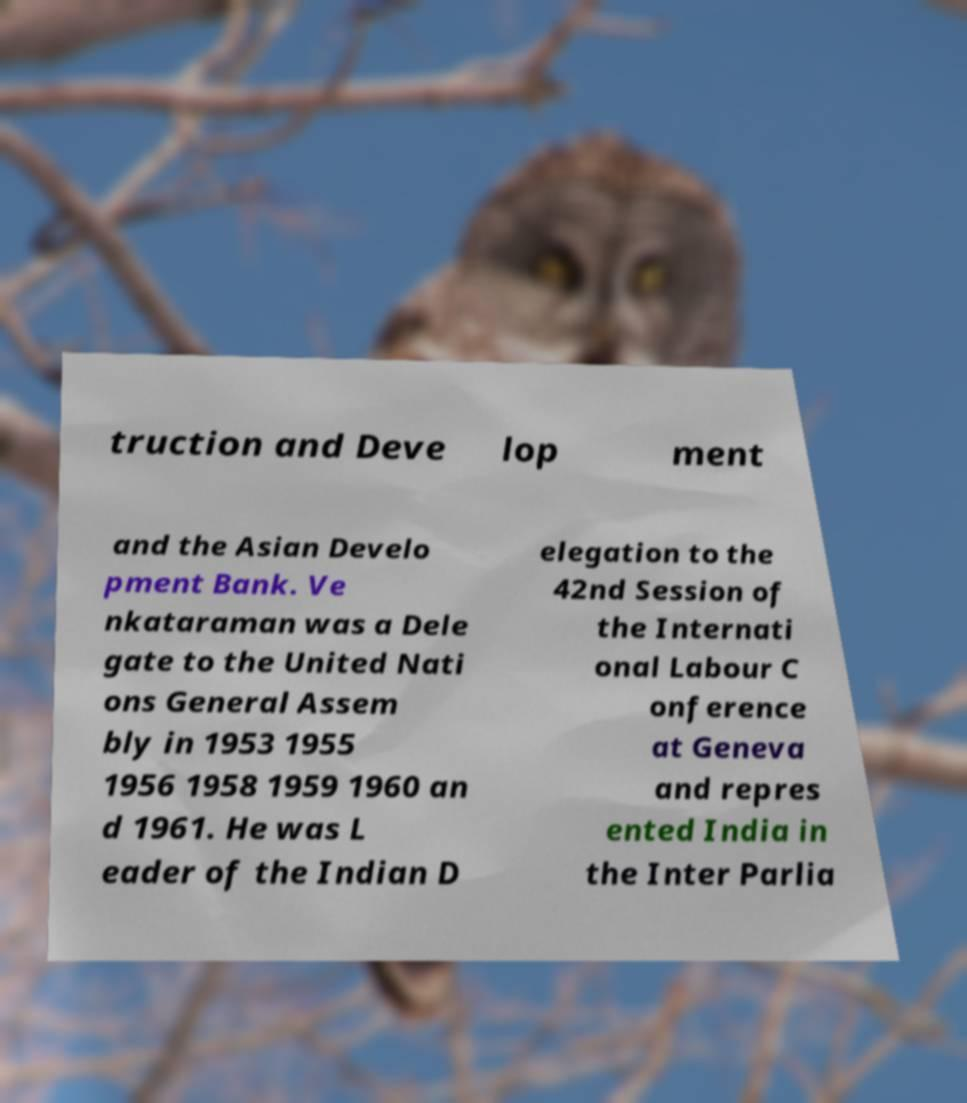Can you accurately transcribe the text from the provided image for me? truction and Deve lop ment and the Asian Develo pment Bank. Ve nkataraman was a Dele gate to the United Nati ons General Assem bly in 1953 1955 1956 1958 1959 1960 an d 1961. He was L eader of the Indian D elegation to the 42nd Session of the Internati onal Labour C onference at Geneva and repres ented India in the Inter Parlia 